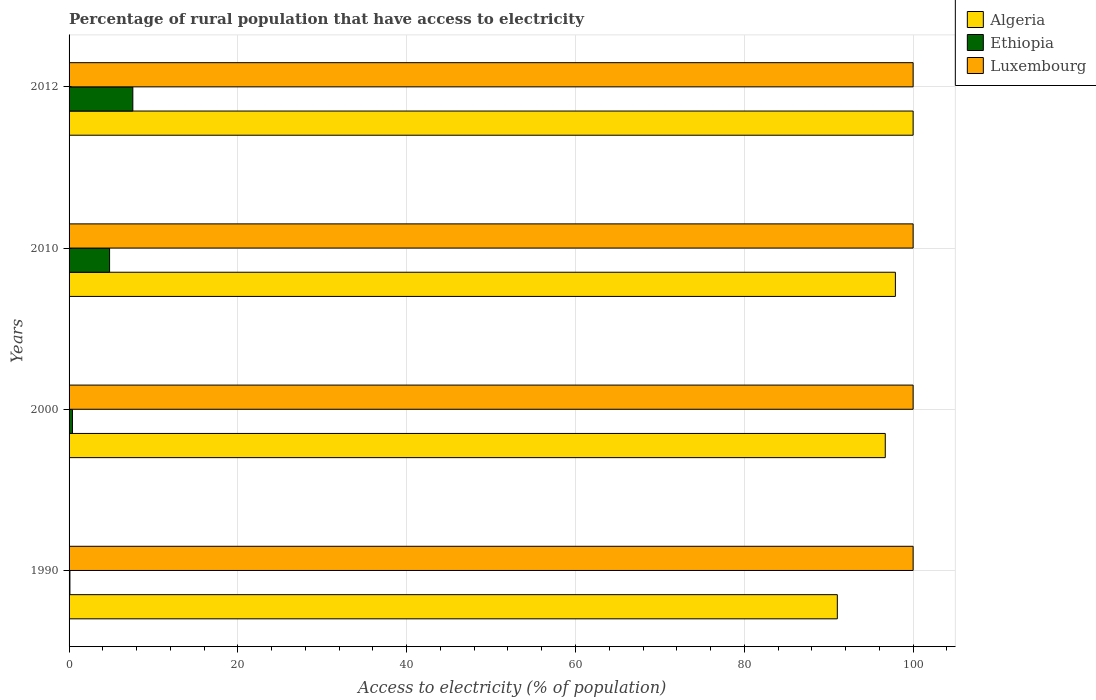How many different coloured bars are there?
Offer a terse response. 3. How many groups of bars are there?
Ensure brevity in your answer.  4. Are the number of bars per tick equal to the number of legend labels?
Give a very brief answer. Yes. How many bars are there on the 2nd tick from the top?
Offer a very short reply. 3. What is the label of the 3rd group of bars from the top?
Make the answer very short. 2000. In how many cases, is the number of bars for a given year not equal to the number of legend labels?
Make the answer very short. 0. What is the percentage of rural population that have access to electricity in Luxembourg in 1990?
Make the answer very short. 100. Across all years, what is the maximum percentage of rural population that have access to electricity in Ethiopia?
Your answer should be very brief. 7.55. In which year was the percentage of rural population that have access to electricity in Ethiopia minimum?
Offer a terse response. 1990. What is the total percentage of rural population that have access to electricity in Ethiopia in the graph?
Ensure brevity in your answer.  12.85. What is the difference between the percentage of rural population that have access to electricity in Ethiopia in 1990 and that in 2000?
Your response must be concise. -0.3. What is the difference between the percentage of rural population that have access to electricity in Luxembourg in 1990 and the percentage of rural population that have access to electricity in Ethiopia in 2012?
Give a very brief answer. 92.45. What is the average percentage of rural population that have access to electricity in Ethiopia per year?
Offer a very short reply. 3.21. In the year 2000, what is the difference between the percentage of rural population that have access to electricity in Luxembourg and percentage of rural population that have access to electricity in Algeria?
Ensure brevity in your answer.  3.3. Is the percentage of rural population that have access to electricity in Luxembourg in 2000 less than that in 2010?
Keep it short and to the point. No. Is the difference between the percentage of rural population that have access to electricity in Luxembourg in 1990 and 2000 greater than the difference between the percentage of rural population that have access to electricity in Algeria in 1990 and 2000?
Give a very brief answer. Yes. What is the difference between the highest and the lowest percentage of rural population that have access to electricity in Ethiopia?
Offer a terse response. 7.45. In how many years, is the percentage of rural population that have access to electricity in Ethiopia greater than the average percentage of rural population that have access to electricity in Ethiopia taken over all years?
Your response must be concise. 2. Is the sum of the percentage of rural population that have access to electricity in Ethiopia in 2000 and 2010 greater than the maximum percentage of rural population that have access to electricity in Algeria across all years?
Provide a short and direct response. No. What does the 2nd bar from the top in 2012 represents?
Make the answer very short. Ethiopia. What does the 1st bar from the bottom in 2000 represents?
Give a very brief answer. Algeria. Is it the case that in every year, the sum of the percentage of rural population that have access to electricity in Ethiopia and percentage of rural population that have access to electricity in Luxembourg is greater than the percentage of rural population that have access to electricity in Algeria?
Offer a very short reply. Yes. Are all the bars in the graph horizontal?
Provide a succinct answer. Yes. What is the difference between two consecutive major ticks on the X-axis?
Provide a short and direct response. 20. Are the values on the major ticks of X-axis written in scientific E-notation?
Your answer should be compact. No. Does the graph contain any zero values?
Make the answer very short. No. Does the graph contain grids?
Provide a succinct answer. Yes. How are the legend labels stacked?
Offer a very short reply. Vertical. What is the title of the graph?
Keep it short and to the point. Percentage of rural population that have access to electricity. Does "United Arab Emirates" appear as one of the legend labels in the graph?
Give a very brief answer. No. What is the label or title of the X-axis?
Offer a very short reply. Access to electricity (% of population). What is the Access to electricity (% of population) of Algeria in 1990?
Your response must be concise. 91.02. What is the Access to electricity (% of population) of Ethiopia in 1990?
Provide a succinct answer. 0.1. What is the Access to electricity (% of population) of Luxembourg in 1990?
Offer a terse response. 100. What is the Access to electricity (% of population) of Algeria in 2000?
Your answer should be very brief. 96.7. What is the Access to electricity (% of population) in Ethiopia in 2000?
Give a very brief answer. 0.4. What is the Access to electricity (% of population) of Algeria in 2010?
Provide a succinct answer. 97.9. What is the Access to electricity (% of population) in Algeria in 2012?
Offer a terse response. 100. What is the Access to electricity (% of population) of Ethiopia in 2012?
Give a very brief answer. 7.55. Across all years, what is the maximum Access to electricity (% of population) of Ethiopia?
Provide a succinct answer. 7.55. Across all years, what is the minimum Access to electricity (% of population) in Algeria?
Provide a short and direct response. 91.02. What is the total Access to electricity (% of population) of Algeria in the graph?
Your answer should be compact. 385.62. What is the total Access to electricity (% of population) in Ethiopia in the graph?
Offer a very short reply. 12.85. What is the total Access to electricity (% of population) in Luxembourg in the graph?
Provide a short and direct response. 400. What is the difference between the Access to electricity (% of population) of Algeria in 1990 and that in 2000?
Offer a terse response. -5.68. What is the difference between the Access to electricity (% of population) of Algeria in 1990 and that in 2010?
Ensure brevity in your answer.  -6.88. What is the difference between the Access to electricity (% of population) of Luxembourg in 1990 and that in 2010?
Your answer should be very brief. 0. What is the difference between the Access to electricity (% of population) in Algeria in 1990 and that in 2012?
Offer a terse response. -8.98. What is the difference between the Access to electricity (% of population) in Ethiopia in 1990 and that in 2012?
Provide a short and direct response. -7.45. What is the difference between the Access to electricity (% of population) in Luxembourg in 1990 and that in 2012?
Provide a short and direct response. 0. What is the difference between the Access to electricity (% of population) in Algeria in 2000 and that in 2010?
Provide a short and direct response. -1.2. What is the difference between the Access to electricity (% of population) of Ethiopia in 2000 and that in 2010?
Offer a terse response. -4.4. What is the difference between the Access to electricity (% of population) in Luxembourg in 2000 and that in 2010?
Your answer should be compact. 0. What is the difference between the Access to electricity (% of population) of Ethiopia in 2000 and that in 2012?
Your response must be concise. -7.15. What is the difference between the Access to electricity (% of population) in Ethiopia in 2010 and that in 2012?
Offer a terse response. -2.75. What is the difference between the Access to electricity (% of population) of Algeria in 1990 and the Access to electricity (% of population) of Ethiopia in 2000?
Provide a short and direct response. 90.62. What is the difference between the Access to electricity (% of population) of Algeria in 1990 and the Access to electricity (% of population) of Luxembourg in 2000?
Provide a succinct answer. -8.98. What is the difference between the Access to electricity (% of population) of Ethiopia in 1990 and the Access to electricity (% of population) of Luxembourg in 2000?
Offer a terse response. -99.9. What is the difference between the Access to electricity (% of population) of Algeria in 1990 and the Access to electricity (% of population) of Ethiopia in 2010?
Give a very brief answer. 86.22. What is the difference between the Access to electricity (% of population) in Algeria in 1990 and the Access to electricity (% of population) in Luxembourg in 2010?
Your answer should be compact. -8.98. What is the difference between the Access to electricity (% of population) in Ethiopia in 1990 and the Access to electricity (% of population) in Luxembourg in 2010?
Offer a terse response. -99.9. What is the difference between the Access to electricity (% of population) of Algeria in 1990 and the Access to electricity (% of population) of Ethiopia in 2012?
Provide a succinct answer. 83.47. What is the difference between the Access to electricity (% of population) in Algeria in 1990 and the Access to electricity (% of population) in Luxembourg in 2012?
Ensure brevity in your answer.  -8.98. What is the difference between the Access to electricity (% of population) in Ethiopia in 1990 and the Access to electricity (% of population) in Luxembourg in 2012?
Your answer should be very brief. -99.9. What is the difference between the Access to electricity (% of population) of Algeria in 2000 and the Access to electricity (% of population) of Ethiopia in 2010?
Provide a short and direct response. 91.9. What is the difference between the Access to electricity (% of population) of Ethiopia in 2000 and the Access to electricity (% of population) of Luxembourg in 2010?
Your answer should be compact. -99.6. What is the difference between the Access to electricity (% of population) of Algeria in 2000 and the Access to electricity (% of population) of Ethiopia in 2012?
Give a very brief answer. 89.15. What is the difference between the Access to electricity (% of population) of Ethiopia in 2000 and the Access to electricity (% of population) of Luxembourg in 2012?
Make the answer very short. -99.6. What is the difference between the Access to electricity (% of population) of Algeria in 2010 and the Access to electricity (% of population) of Ethiopia in 2012?
Keep it short and to the point. 90.35. What is the difference between the Access to electricity (% of population) in Algeria in 2010 and the Access to electricity (% of population) in Luxembourg in 2012?
Provide a succinct answer. -2.1. What is the difference between the Access to electricity (% of population) in Ethiopia in 2010 and the Access to electricity (% of population) in Luxembourg in 2012?
Your answer should be compact. -95.2. What is the average Access to electricity (% of population) in Algeria per year?
Your answer should be very brief. 96.4. What is the average Access to electricity (% of population) of Ethiopia per year?
Your answer should be compact. 3.21. What is the average Access to electricity (% of population) in Luxembourg per year?
Offer a very short reply. 100. In the year 1990, what is the difference between the Access to electricity (% of population) of Algeria and Access to electricity (% of population) of Ethiopia?
Your answer should be very brief. 90.92. In the year 1990, what is the difference between the Access to electricity (% of population) of Algeria and Access to electricity (% of population) of Luxembourg?
Offer a terse response. -8.98. In the year 1990, what is the difference between the Access to electricity (% of population) in Ethiopia and Access to electricity (% of population) in Luxembourg?
Offer a terse response. -99.9. In the year 2000, what is the difference between the Access to electricity (% of population) in Algeria and Access to electricity (% of population) in Ethiopia?
Offer a very short reply. 96.3. In the year 2000, what is the difference between the Access to electricity (% of population) in Ethiopia and Access to electricity (% of population) in Luxembourg?
Ensure brevity in your answer.  -99.6. In the year 2010, what is the difference between the Access to electricity (% of population) in Algeria and Access to electricity (% of population) in Ethiopia?
Your answer should be very brief. 93.1. In the year 2010, what is the difference between the Access to electricity (% of population) in Algeria and Access to electricity (% of population) in Luxembourg?
Your answer should be very brief. -2.1. In the year 2010, what is the difference between the Access to electricity (% of population) of Ethiopia and Access to electricity (% of population) of Luxembourg?
Provide a succinct answer. -95.2. In the year 2012, what is the difference between the Access to electricity (% of population) in Algeria and Access to electricity (% of population) in Ethiopia?
Keep it short and to the point. 92.45. In the year 2012, what is the difference between the Access to electricity (% of population) in Algeria and Access to electricity (% of population) in Luxembourg?
Provide a short and direct response. 0. In the year 2012, what is the difference between the Access to electricity (% of population) in Ethiopia and Access to electricity (% of population) in Luxembourg?
Make the answer very short. -92.45. What is the ratio of the Access to electricity (% of population) of Algeria in 1990 to that in 2000?
Provide a short and direct response. 0.94. What is the ratio of the Access to electricity (% of population) in Algeria in 1990 to that in 2010?
Make the answer very short. 0.93. What is the ratio of the Access to electricity (% of population) in Ethiopia in 1990 to that in 2010?
Offer a terse response. 0.02. What is the ratio of the Access to electricity (% of population) in Luxembourg in 1990 to that in 2010?
Your response must be concise. 1. What is the ratio of the Access to electricity (% of population) in Algeria in 1990 to that in 2012?
Offer a very short reply. 0.91. What is the ratio of the Access to electricity (% of population) of Ethiopia in 1990 to that in 2012?
Provide a short and direct response. 0.01. What is the ratio of the Access to electricity (% of population) of Luxembourg in 1990 to that in 2012?
Make the answer very short. 1. What is the ratio of the Access to electricity (% of population) in Algeria in 2000 to that in 2010?
Offer a very short reply. 0.99. What is the ratio of the Access to electricity (% of population) in Ethiopia in 2000 to that in 2010?
Give a very brief answer. 0.08. What is the ratio of the Access to electricity (% of population) of Luxembourg in 2000 to that in 2010?
Offer a terse response. 1. What is the ratio of the Access to electricity (% of population) of Ethiopia in 2000 to that in 2012?
Provide a short and direct response. 0.05. What is the ratio of the Access to electricity (% of population) of Algeria in 2010 to that in 2012?
Ensure brevity in your answer.  0.98. What is the ratio of the Access to electricity (% of population) in Ethiopia in 2010 to that in 2012?
Offer a very short reply. 0.64. What is the difference between the highest and the second highest Access to electricity (% of population) in Algeria?
Ensure brevity in your answer.  2.1. What is the difference between the highest and the second highest Access to electricity (% of population) of Ethiopia?
Provide a short and direct response. 2.75. What is the difference between the highest and the lowest Access to electricity (% of population) in Algeria?
Keep it short and to the point. 8.98. What is the difference between the highest and the lowest Access to electricity (% of population) of Ethiopia?
Offer a very short reply. 7.45. What is the difference between the highest and the lowest Access to electricity (% of population) of Luxembourg?
Your answer should be very brief. 0. 